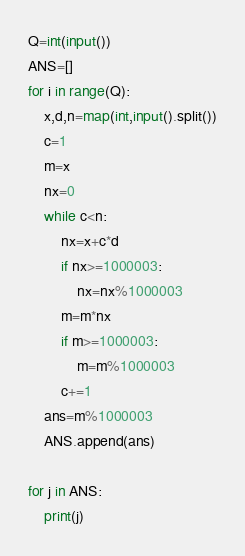<code> <loc_0><loc_0><loc_500><loc_500><_Python_>Q=int(input())
ANS=[]
for i in range(Q):
    x,d,n=map(int,input().split())
    c=1
    m=x
    nx=0
    while c<n:
        nx=x+c*d
        if nx>=1000003:
            nx=nx%1000003
        m=m*nx
        if m>=1000003:
            m=m%1000003
        c+=1
    ans=m%1000003
    ANS.append(ans)

for j in ANS:
    print(j)
</code> 